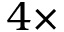<formula> <loc_0><loc_0><loc_500><loc_500>4 \times</formula> 